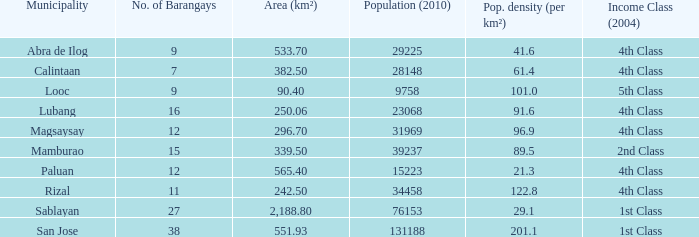What was the smallist population in 2010? 9758.0. 